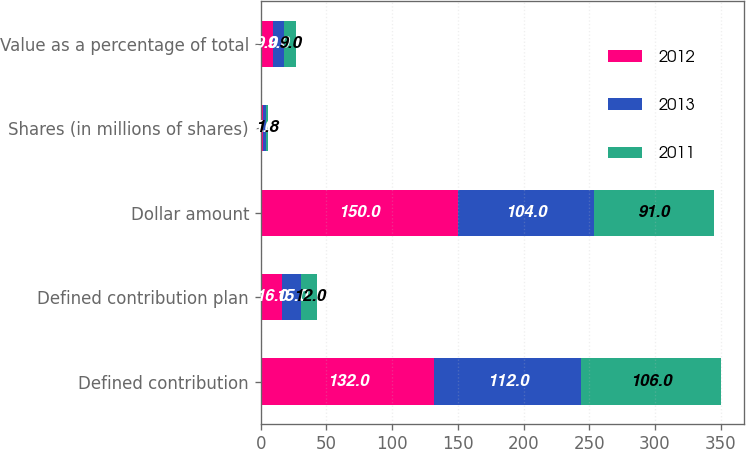Convert chart. <chart><loc_0><loc_0><loc_500><loc_500><stacked_bar_chart><ecel><fcel>Defined contribution<fcel>Defined contribution plan<fcel>Dollar amount<fcel>Shares (in millions of shares)<fcel>Value as a percentage of total<nl><fcel>2012<fcel>132<fcel>16<fcel>150<fcel>2<fcel>9<nl><fcel>2013<fcel>112<fcel>15<fcel>104<fcel>1.9<fcel>9<nl><fcel>2011<fcel>106<fcel>12<fcel>91<fcel>1.8<fcel>9<nl></chart> 